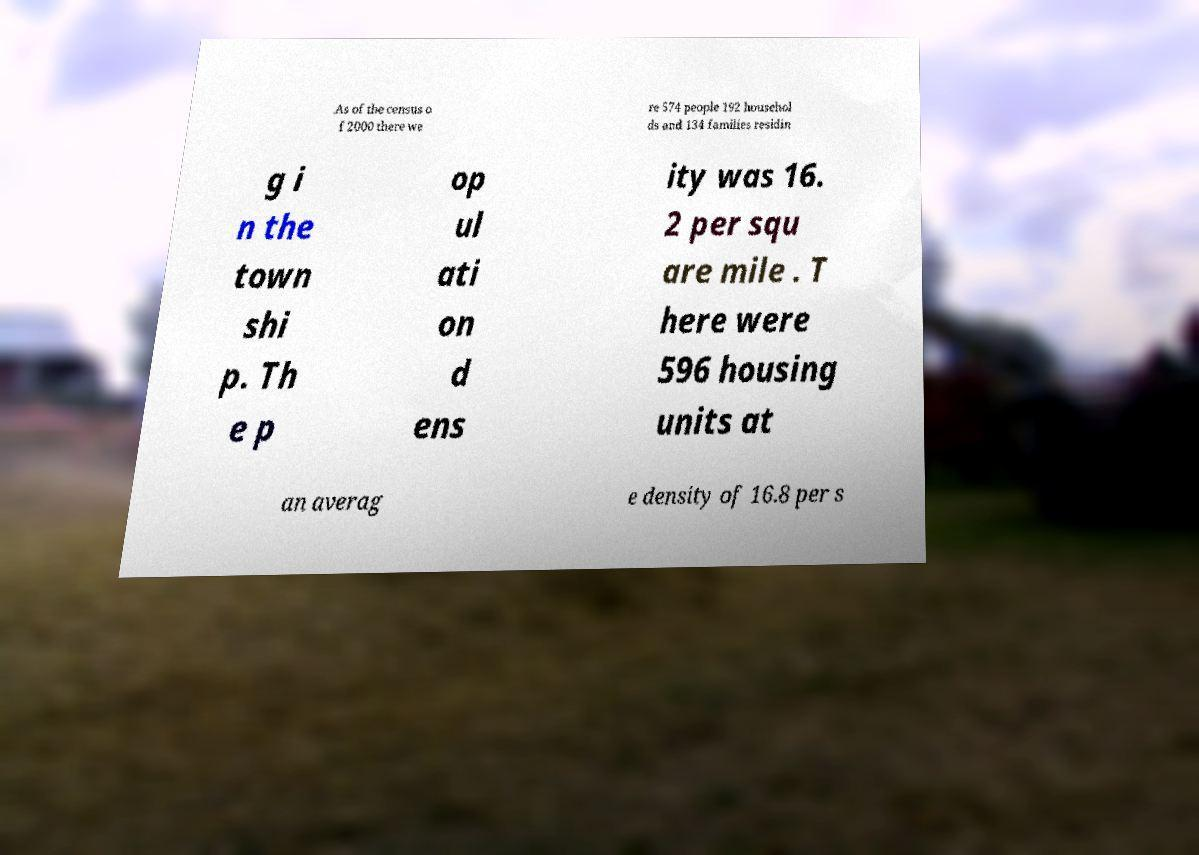Please read and relay the text visible in this image. What does it say? .As of the census o f 2000 there we re 574 people 192 househol ds and 134 families residin g i n the town shi p. Th e p op ul ati on d ens ity was 16. 2 per squ are mile . T here were 596 housing units at an averag e density of 16.8 per s 